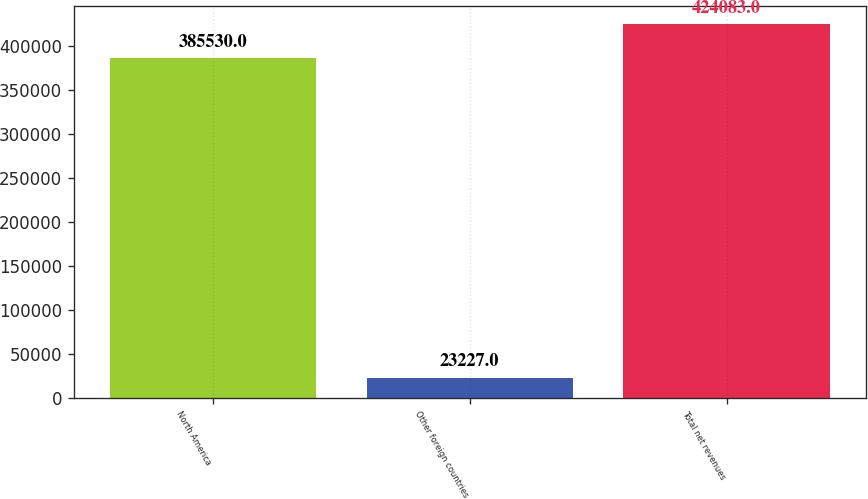Convert chart to OTSL. <chart><loc_0><loc_0><loc_500><loc_500><bar_chart><fcel>North America<fcel>Other foreign countries<fcel>Total net revenues<nl><fcel>385530<fcel>23227<fcel>424083<nl></chart> 